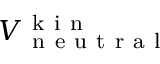<formula> <loc_0><loc_0><loc_500><loc_500>V _ { n e u t r a l } ^ { k i n }</formula> 